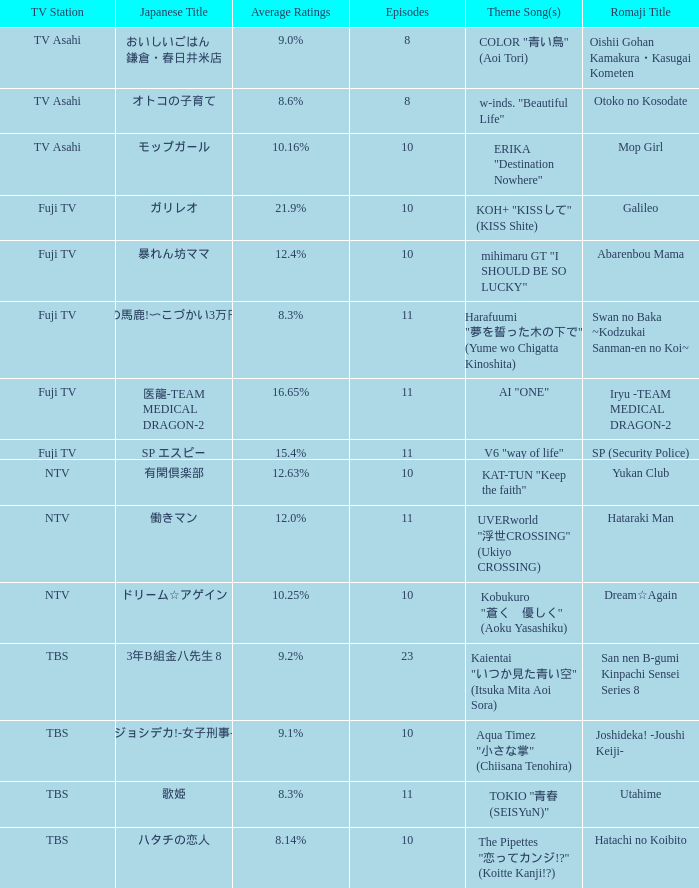What is the Theme Song of the show on Fuji TV Station with Average Ratings of 16.65%? AI "ONE". 